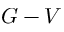<formula> <loc_0><loc_0><loc_500><loc_500>G - V</formula> 